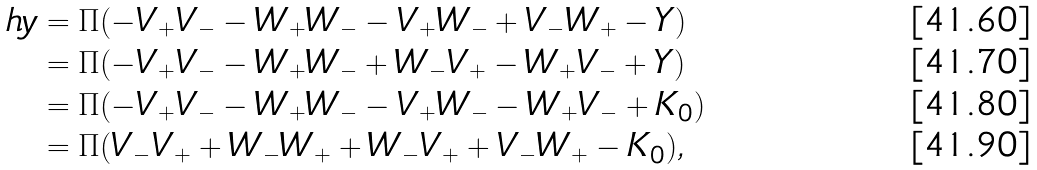Convert formula to latex. <formula><loc_0><loc_0><loc_500><loc_500>\ h y & = \Pi ( - V _ { + } V _ { - } - W _ { + } W _ { - } - V _ { + } W _ { - } + V _ { - } W _ { + } - Y ) \\ & = \Pi ( - V _ { + } V _ { - } - W _ { + } W _ { - } + W _ { - } V _ { + } - W _ { + } V _ { - } + Y ) \\ & = \Pi ( - V _ { + } V _ { - } - W _ { + } W _ { - } - V _ { + } W _ { - } - W _ { + } V _ { - } + K _ { 0 } ) \\ & = \Pi ( V _ { - } V _ { + } + W _ { - } W _ { + } + W _ { - } V _ { + } + V _ { - } W _ { + } - K _ { 0 } ) ,</formula> 